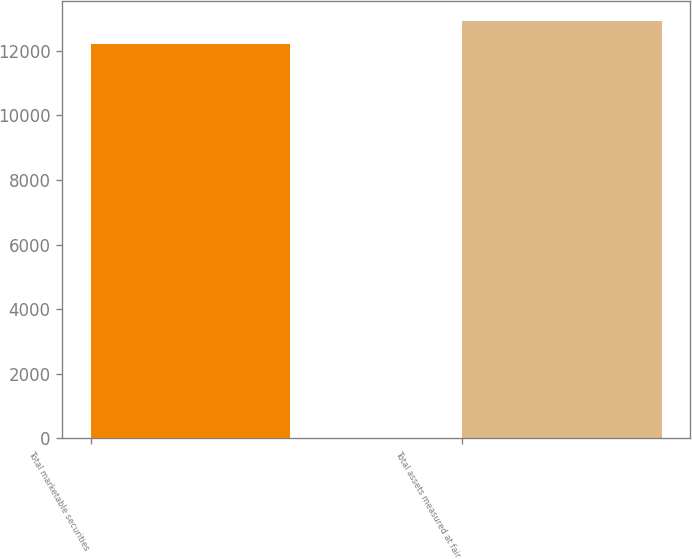<chart> <loc_0><loc_0><loc_500><loc_500><bar_chart><fcel>Total marketable securities<fcel>Total assets measured at fair<nl><fcel>12216<fcel>12914<nl></chart> 